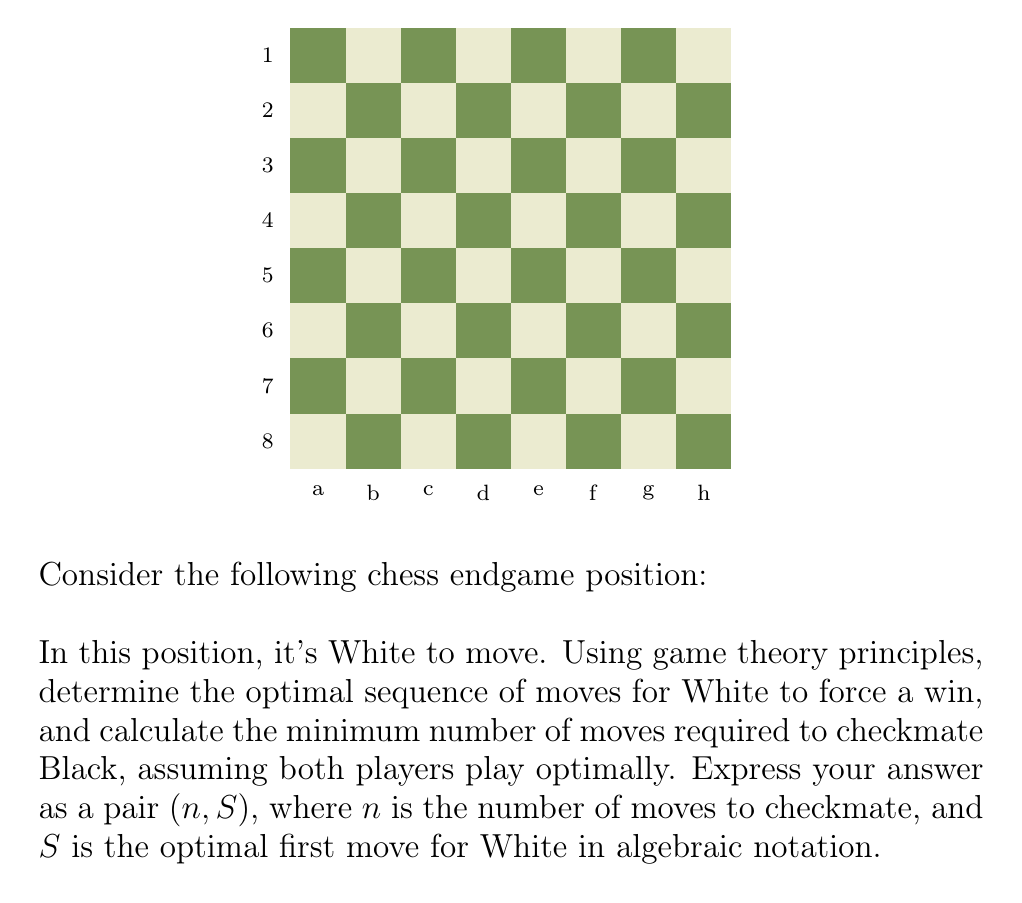What is the answer to this math problem? To solve this problem, we'll use the concept of minimax from game theory, considering that both players will make optimal moves. Let's analyze step-by-step:

1) First, we identify the key features of the position:
   - White has a king on e1 and a rook on h2
   - Black has a lone king on e8
   - It's White's turn to move

2) The optimal strategy for White is to use the rook to restrict Black's king to the last rank, then bring the white king up to assist in the checkmate.

3) The sequence of optimal moves:

   Move 1: White plays Rh7, restricting Black's king to the 8th rank.
   Black's best response is Kd8 or Kf8.

   Move 2: White plays Rh8+, forcing Black's king to e7.

   Move 3: White plays Rh7+, forcing Black's king back to the 8th rank.
   Black's best response is Kd8 or Kf8.

   Move 4: White plays Ke2, advancing the king.
   Black's best response is to stay on the 8th rank.

   Moves 5-7: White continues to advance the king (Ke3, Ke4, Ke5) while Black's king is trapped on the 8th rank.

   Move 8: White plays Ke6, and Black's king is restricted to d8 and f8.

   Move 9: If Black's king is on f8, White plays Rh8#. If Black's king is on d8, White plays Rh8+ forcing Ke8, then Re8#.

4) Counting the moves, we see that it takes White 9 moves to force checkmate, assuming optimal play from both sides.

5) The optimal first move for White is Rh7, which we express in algebraic notation as "Rh7".

Therefore, the solution is $(9, \text{Rh7})$.
Answer: $(9, \text{Rh7})$ 